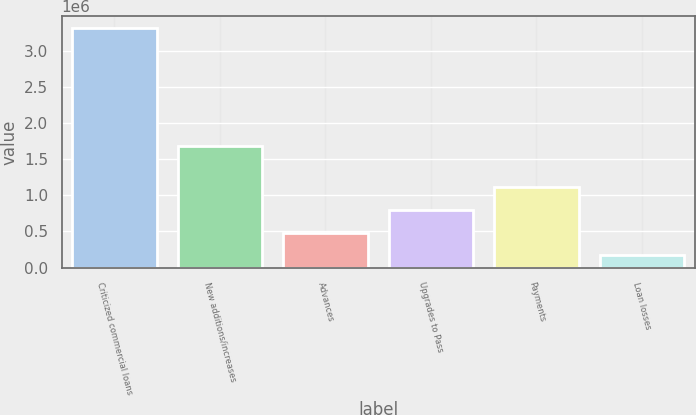<chart> <loc_0><loc_0><loc_500><loc_500><bar_chart><fcel>Criticized commercial loans<fcel>New additions/increases<fcel>Advances<fcel>Upgrades to Pass<fcel>Payments<fcel>Loan losses<nl><fcel>3.31128e+06<fcel>1.68802e+06<fcel>482490<fcel>796800<fcel>1.11111e+06<fcel>168180<nl></chart> 